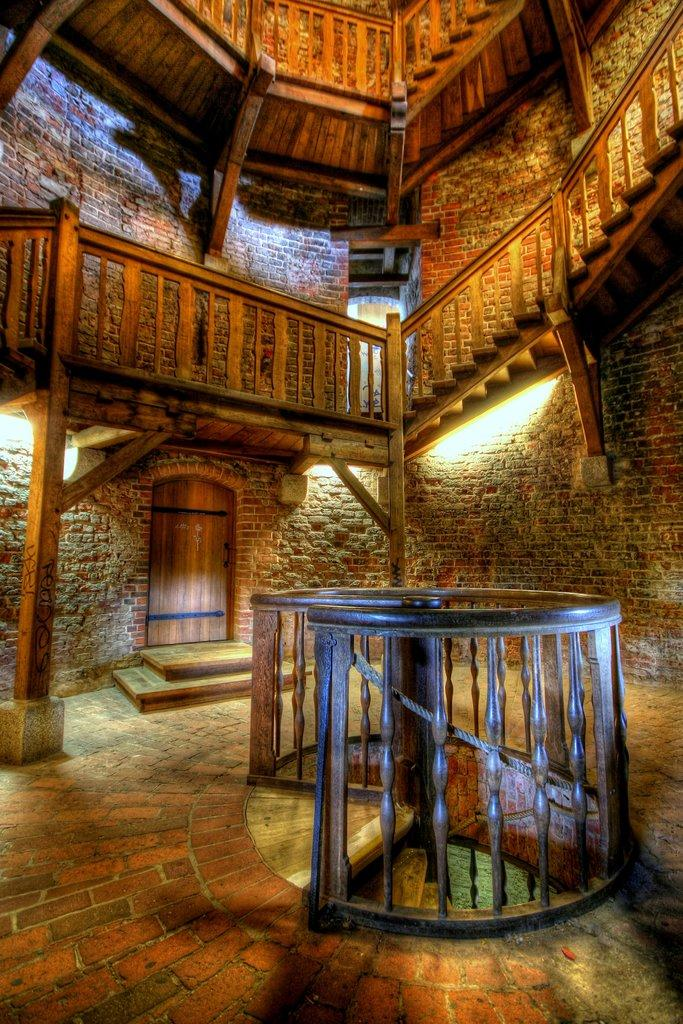What type of location is depicted in the image? The image shows an inner view of a building. What architectural feature is present inside the building? There are stairs inside the building. What safety feature is associated with the stairs? There is a railing associated with the stairs. What can be seen in the background of the image? There is a door, lights, and a wall visible in the background. What type of pancake is being served on the ship in the image? There is no ship or pancake present in the image; it shows an inner view of a building with stairs and a railing. 